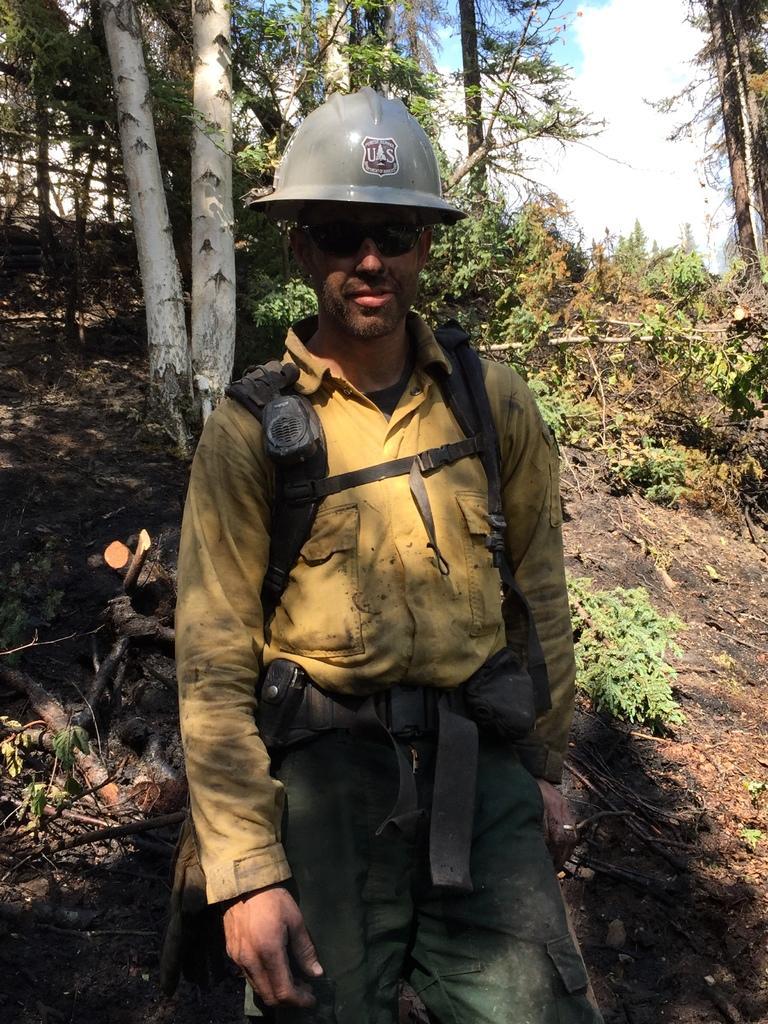In one or two sentences, can you explain what this image depicts? In this picture we can see a man wore a helmet, goggles and standing on the ground, plants, trees and in the background we can see the sky with clouds. 